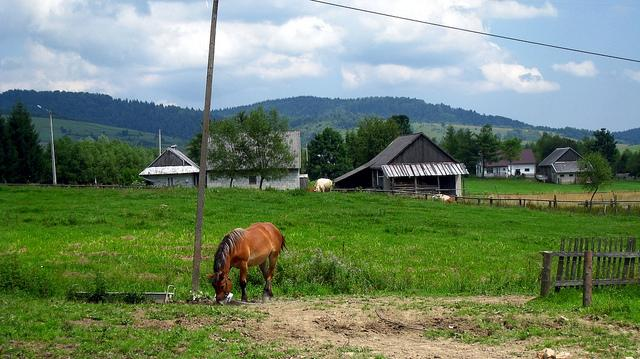What is the large pole near the horse supplying to the homes? Please explain your reasoning. electricity. This is the only option that makes sense. it could have a b on it, but it would also need a. 